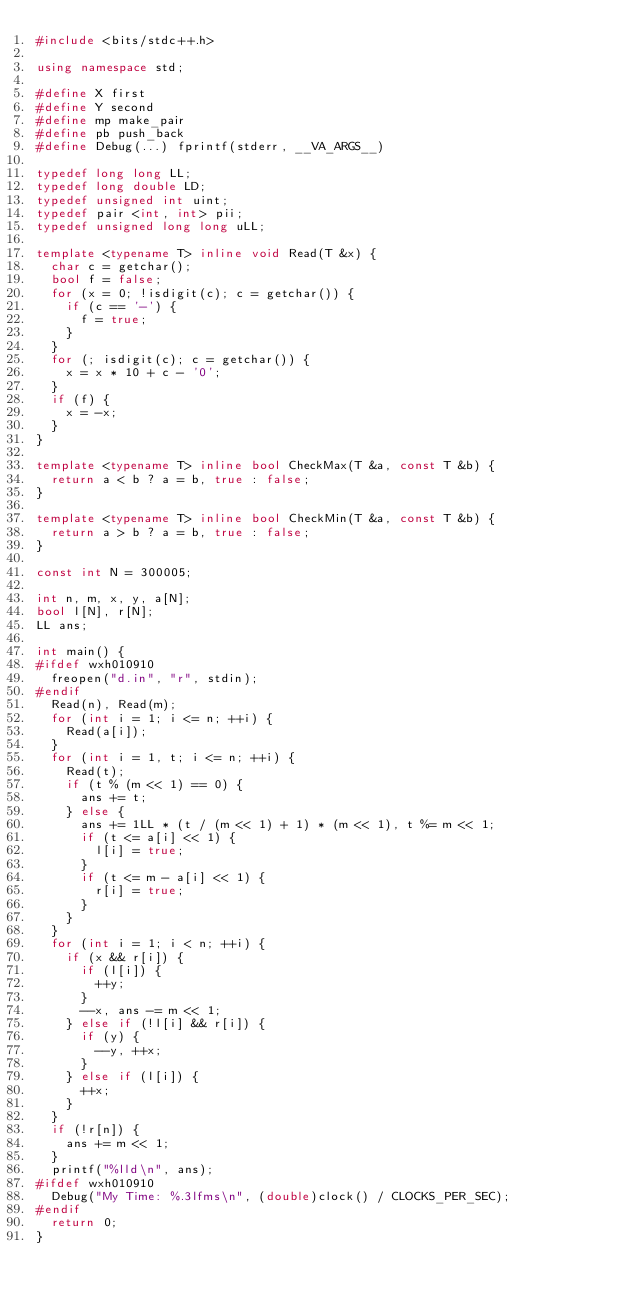Convert code to text. <code><loc_0><loc_0><loc_500><loc_500><_C++_>#include <bits/stdc++.h>

using namespace std;

#define X first
#define Y second
#define mp make_pair
#define pb push_back
#define Debug(...) fprintf(stderr, __VA_ARGS__)

typedef long long LL;
typedef long double LD;
typedef unsigned int uint;
typedef pair <int, int> pii;
typedef unsigned long long uLL;

template <typename T> inline void Read(T &x) {
  char c = getchar();
  bool f = false;
  for (x = 0; !isdigit(c); c = getchar()) {
    if (c == '-') {
      f = true;
    }
  }
  for (; isdigit(c); c = getchar()) {
    x = x * 10 + c - '0';
  }
  if (f) {
    x = -x;
  }
}

template <typename T> inline bool CheckMax(T &a, const T &b) {
  return a < b ? a = b, true : false;
}

template <typename T> inline bool CheckMin(T &a, const T &b) {
  return a > b ? a = b, true : false;
}

const int N = 300005;

int n, m, x, y, a[N];
bool l[N], r[N];
LL ans;

int main() {
#ifdef wxh010910
  freopen("d.in", "r", stdin);
#endif
  Read(n), Read(m);
  for (int i = 1; i <= n; ++i) {
    Read(a[i]);
  }
  for (int i = 1, t; i <= n; ++i) {
    Read(t);
    if (t % (m << 1) == 0) {
      ans += t;
    } else {
      ans += 1LL * (t / (m << 1) + 1) * (m << 1), t %= m << 1;
      if (t <= a[i] << 1) {
        l[i] = true;
      }
      if (t <= m - a[i] << 1) {
        r[i] = true;
      }
    }
  }
  for (int i = 1; i < n; ++i) {
    if (x && r[i]) {
      if (l[i]) {
        ++y;
      }
      --x, ans -= m << 1;
    } else if (!l[i] && r[i]) {
      if (y) {
        --y, ++x;
      }
    } else if (l[i]) {
      ++x;
    }
  }
  if (!r[n]) {
    ans += m << 1;
  }
  printf("%lld\n", ans);
#ifdef wxh010910
  Debug("My Time: %.3lfms\n", (double)clock() / CLOCKS_PER_SEC);
#endif
  return 0;
}
</code> 